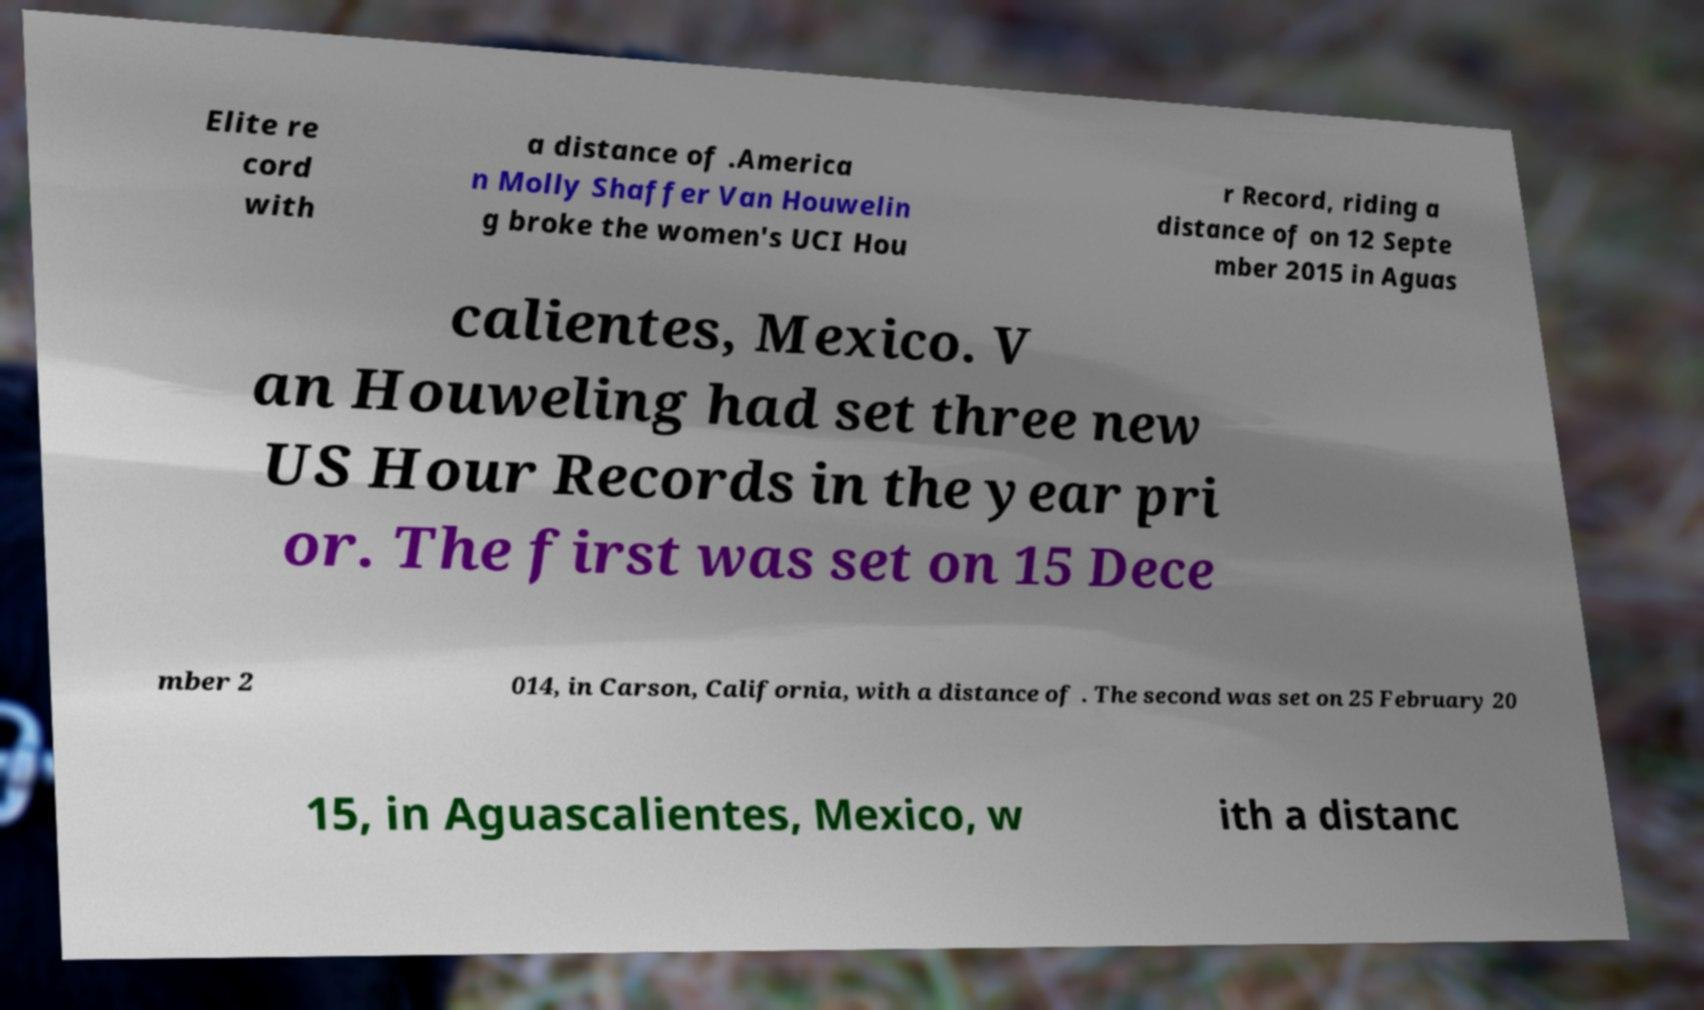For documentation purposes, I need the text within this image transcribed. Could you provide that? Elite re cord with a distance of .America n Molly Shaffer Van Houwelin g broke the women's UCI Hou r Record, riding a distance of on 12 Septe mber 2015 in Aguas calientes, Mexico. V an Houweling had set three new US Hour Records in the year pri or. The first was set on 15 Dece mber 2 014, in Carson, California, with a distance of . The second was set on 25 February 20 15, in Aguascalientes, Mexico, w ith a distanc 